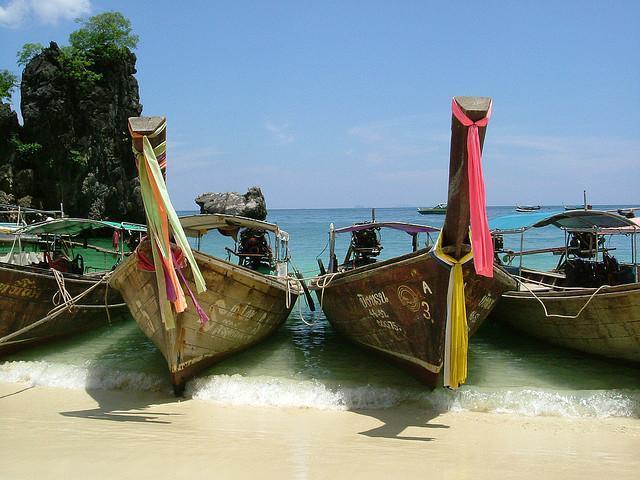How many boats are there?
Give a very brief answer. 4. 